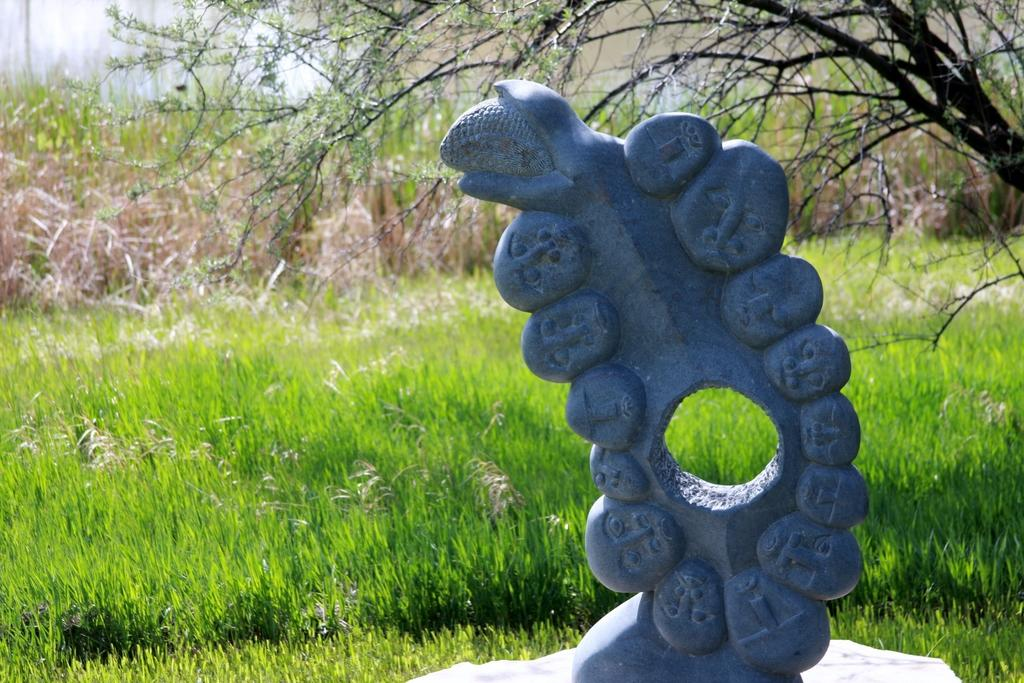What is the main subject of the image? There is a sculpture on a stone in the image. What type of vegetation can be seen in the image? There is a grass plant and dried plants visible in the image. What other natural element is present in the image? There is a tree in the image. How does the guide help visitors navigate the area in the image? There is no guide present in the image; it features a sculpture, grass plant, dried plants, and a tree. 